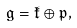Convert formula to latex. <formula><loc_0><loc_0><loc_500><loc_500>\mathfrak g = \mathfrak k \oplus \mathfrak p ,</formula> 